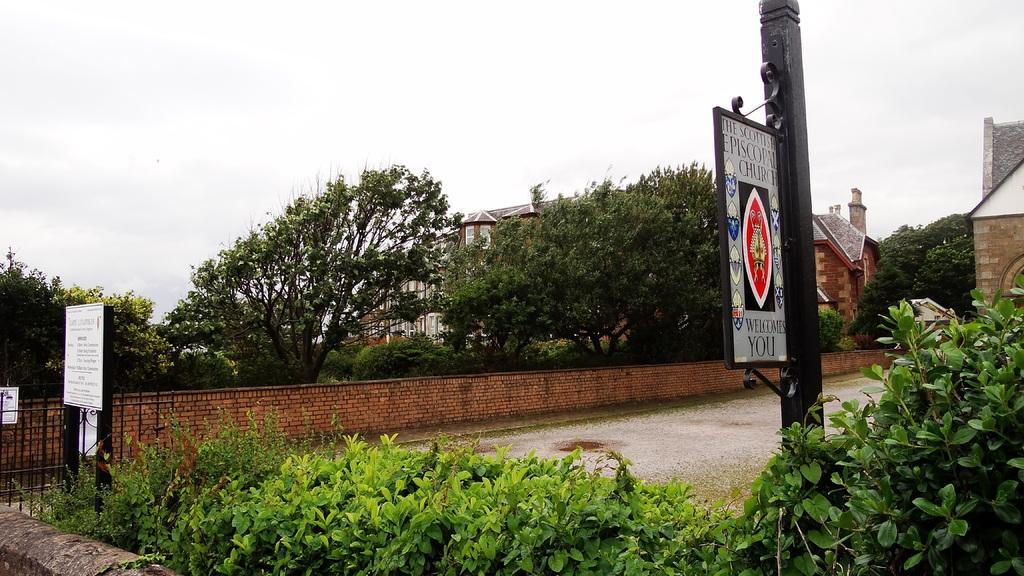Please provide a concise description of this image. In this image we can see houses, there are plants, trees, a gate, there are boards with text written on them, also we can see the wall, and the sky. 